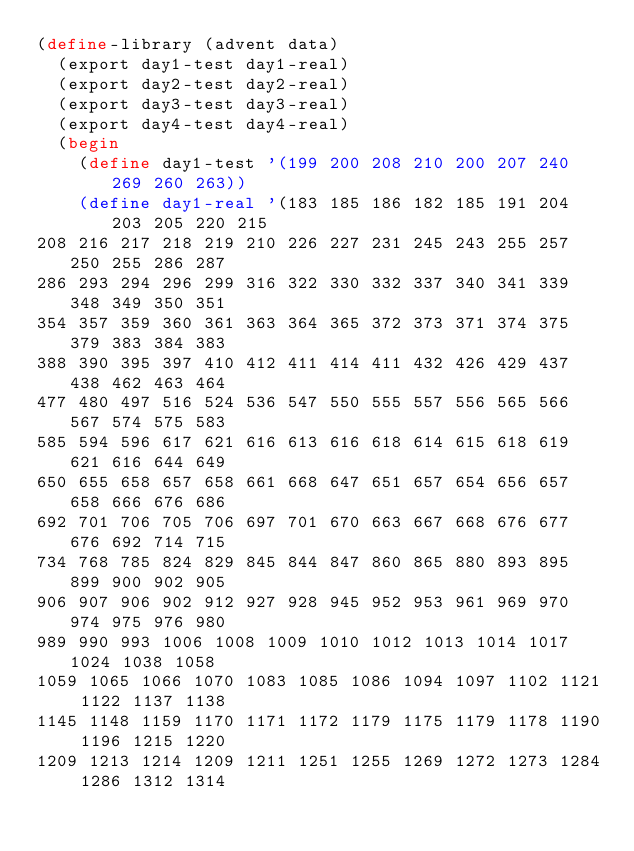Convert code to text. <code><loc_0><loc_0><loc_500><loc_500><_Scheme_>(define-library (advent data)
  (export day1-test day1-real)
  (export day2-test day2-real)
  (export day3-test day3-real)
  (export day4-test day4-real)
  (begin 
    (define day1-test '(199 200 208 210 200 207 240 269 260 263))
    (define day1-real '(183 185 186 182 185 191 204 203 205 220 215
208 216 217 218 219 210 226 227 231 245 243 255 257 250 255 286 287
286 293 294 296 299 316 322 330 332 337 340 341 339 348 349 350 351
354 357 359 360 361 363 364 365 372 373 371 374 375 379 383 384 383
388 390 395 397 410 412 411 414 411 432 426 429 437 438 462 463 464
477 480 497 516 524 536 547 550 555 557 556 565 566 567 574 575 583
585 594 596 617 621 616 613 616 618 614 615 618 619 621 616 644 649
650 655 658 657 658 661 668 647 651 657 654 656 657 658 666 676 686
692 701 706 705 706 697 701 670 663 667 668 676 677 676 692 714 715
734 768 785 824 829 845 844 847 860 865 880 893 895 899 900 902 905
906 907 906 902 912 927 928 945 952 953 961 969 970 974 975 976 980
989 990 993 1006 1008 1009 1010 1012 1013 1014 1017 1024 1038 1058
1059 1065 1066 1070 1083 1085 1086 1094 1097 1102 1121 1122 1137 1138
1145 1148 1159 1170 1171 1172 1179 1175 1179 1178 1190 1196 1215 1220
1209 1213 1214 1209 1211 1251 1255 1269 1272 1273 1284 1286 1312 1314</code> 